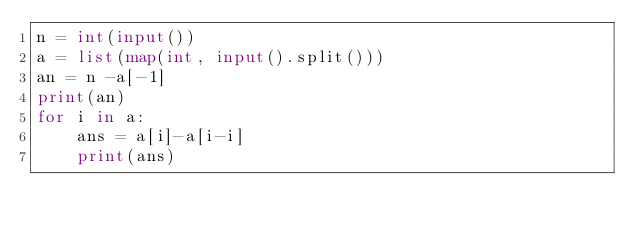<code> <loc_0><loc_0><loc_500><loc_500><_Python_>n = int(input())
a = list(map(int, input().split()))
an = n -a[-1]
print(an)
for i in a:
    ans = a[i]-a[i-i]
    print(ans)
    </code> 